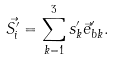<formula> <loc_0><loc_0><loc_500><loc_500>\vec { S ^ { \prime } _ { i } } = \sum _ { k = 1 } ^ { 3 } s ^ { \prime } _ { k } \vec { e } ^ { \prime } _ { b k } .</formula> 